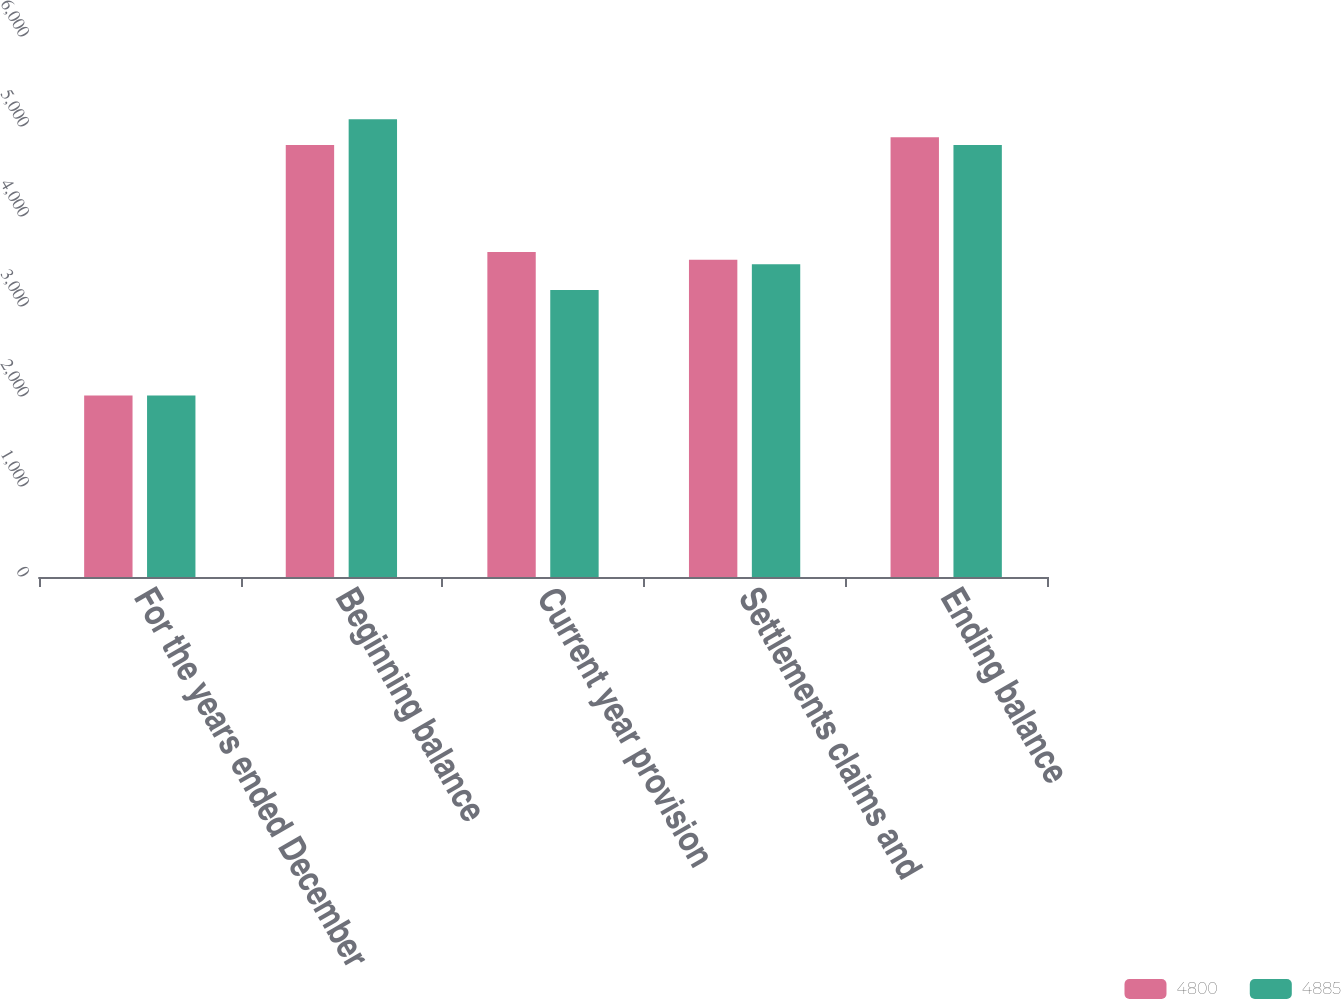<chart> <loc_0><loc_0><loc_500><loc_500><stacked_bar_chart><ecel><fcel>For the years ended December<fcel>Beginning balance<fcel>Current year provision<fcel>Settlements claims and<fcel>Ending balance<nl><fcel>4800<fcel>2017<fcel>4800<fcel>3611<fcel>3526<fcel>4885<nl><fcel>4885<fcel>2016<fcel>5085<fcel>3190<fcel>3475<fcel>4800<nl></chart> 